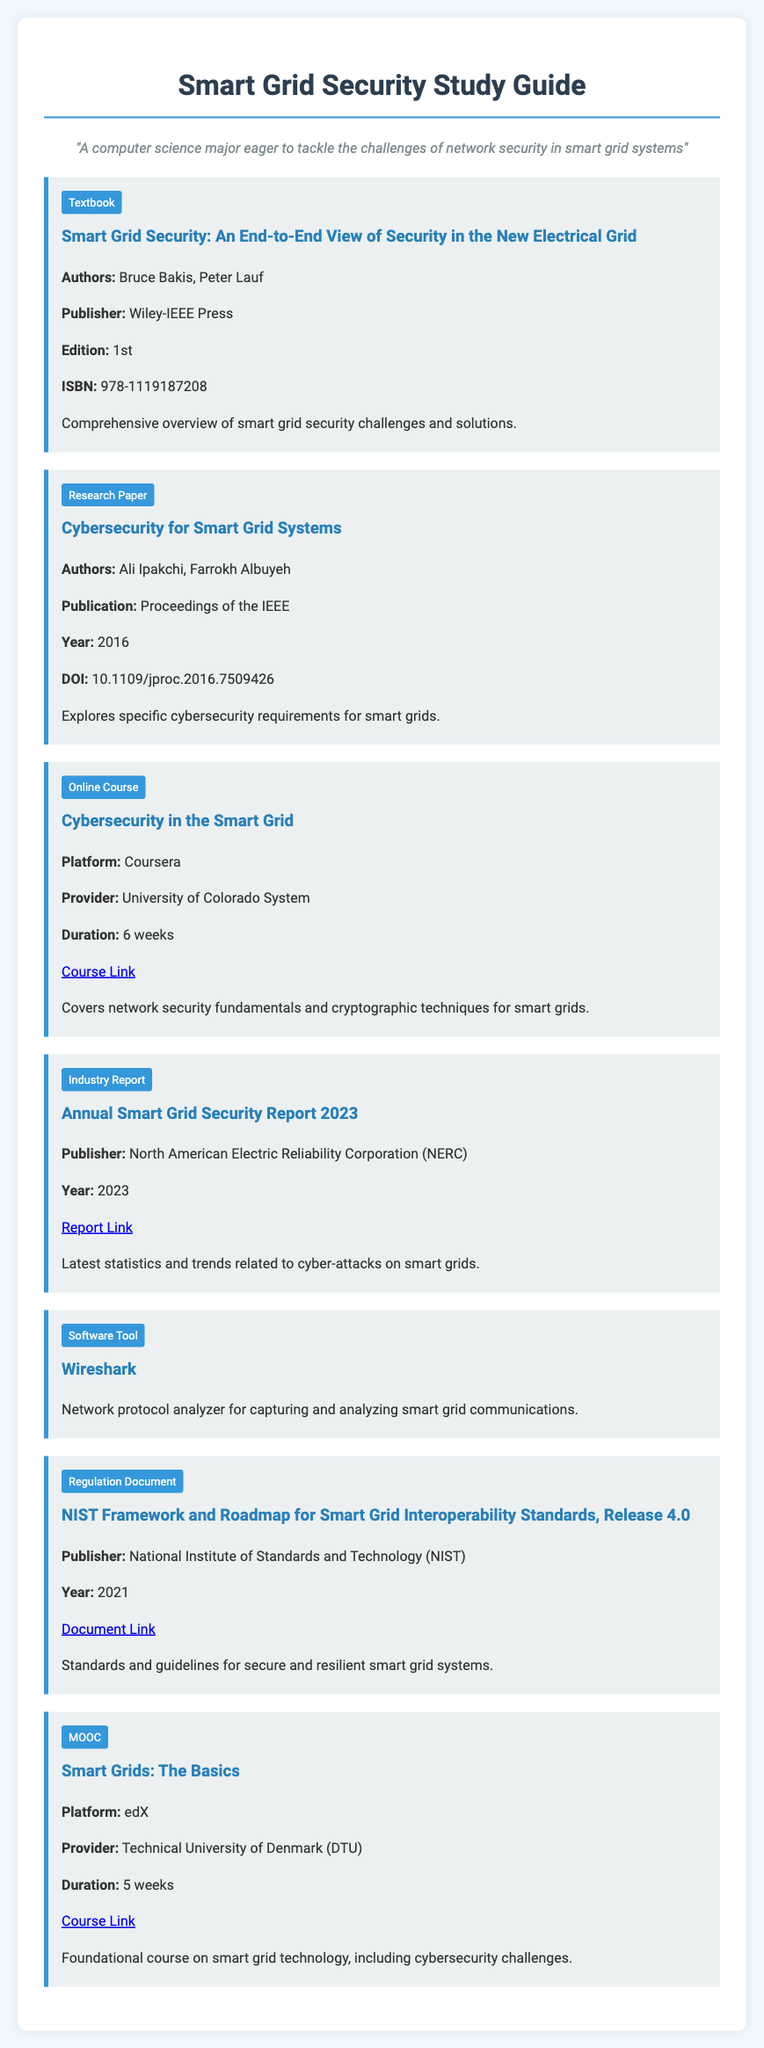What is the title of the textbook? The title of the textbook is specified in the document, which is "Smart Grid Security: An End-to-End View of Security in the New Electrical Grid."
Answer: Smart Grid Security: An End-to-End View of Security in the New Electrical Grid Who are the authors of the research paper? The authors of the research paper are mentioned in the document as Ali Ipakchi and Farrokh Albuyeh.
Answer: Ali Ipakchi, Farrokh Albuyeh What is the year of the NIST document? The document specifies the publication year for the NIST Framework as 2021.
Answer: 2021 How long is the "Cybersecurity in the Smart Grid" course? The duration of the course is noted in the document, which is 6 weeks.
Answer: 6 weeks What type of content is "Wireshark"? The type of content for Wireshark is categorized under software tools in the document.
Answer: Software Tool What is the DOI of the research paper? The document provides the DOI of the research paper as 10.1109/jproc.2016.7509426.
Answer: 10.1109/jproc.2016.7509426 Which organization published the "Annual Smart Grid Security Report 2023"? The document indicates that the report is published by the North American Electric Reliability Corporation (NERC).
Answer: North American Electric Reliability Corporation (NERC) What is the focus of the course "Smart Grids: The Basics"? The content focus is described in the document as foundational course on smart grid technology, including cybersecurity challenges.
Answer: foundational course on smart grid technology, including cybersecurity challenges 